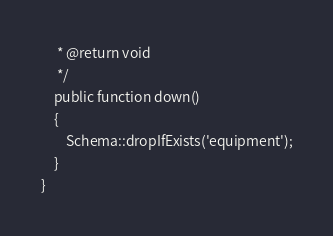<code> <loc_0><loc_0><loc_500><loc_500><_PHP_>     * @return void
     */
    public function down()
    {
        Schema::dropIfExists('equipment');
    }
}
</code> 